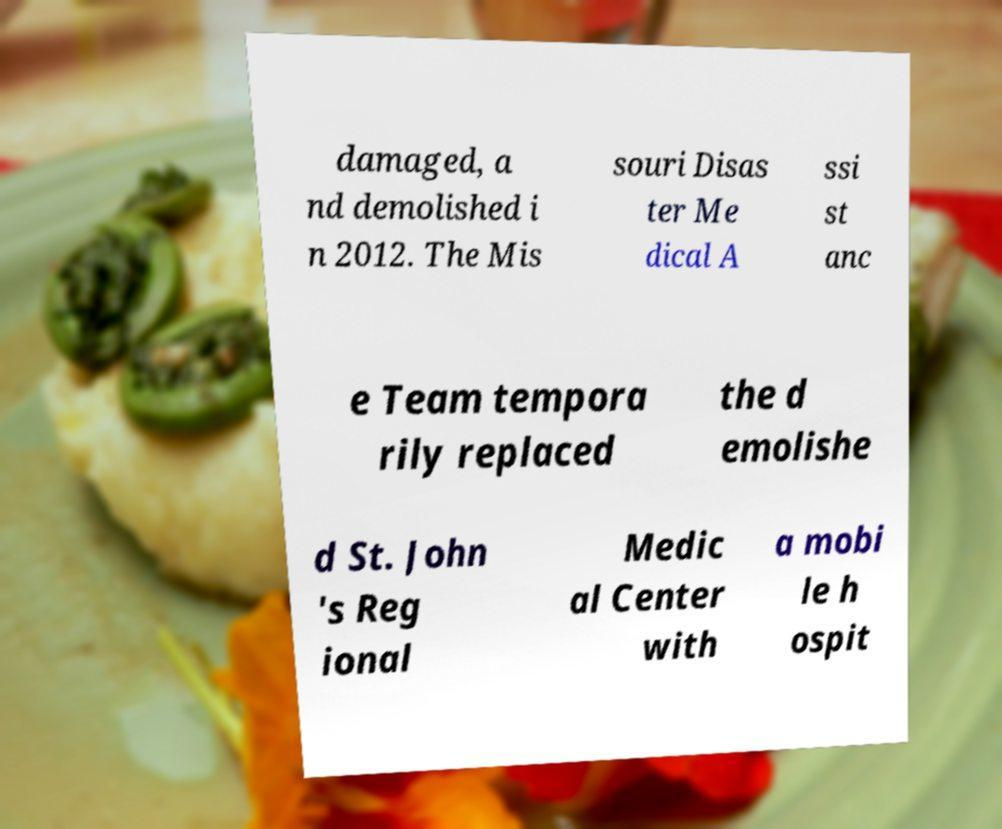What messages or text are displayed in this image? I need them in a readable, typed format. damaged, a nd demolished i n 2012. The Mis souri Disas ter Me dical A ssi st anc e Team tempora rily replaced the d emolishe d St. John 's Reg ional Medic al Center with a mobi le h ospit 